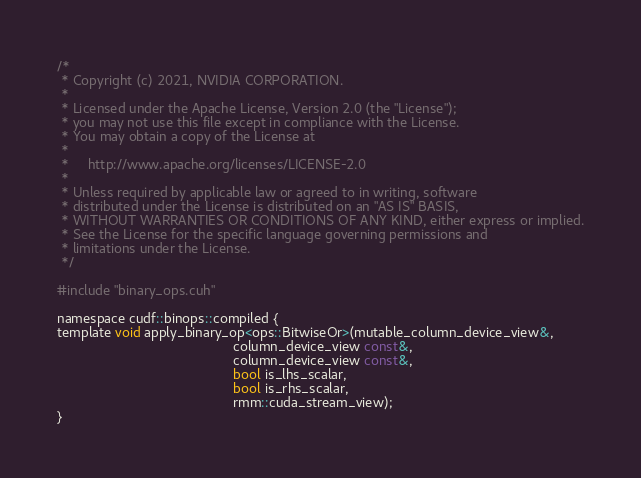<code> <loc_0><loc_0><loc_500><loc_500><_Cuda_>/*
 * Copyright (c) 2021, NVIDIA CORPORATION.
 *
 * Licensed under the Apache License, Version 2.0 (the "License");
 * you may not use this file except in compliance with the License.
 * You may obtain a copy of the License at
 *
 *     http://www.apache.org/licenses/LICENSE-2.0
 *
 * Unless required by applicable law or agreed to in writing, software
 * distributed under the License is distributed on an "AS IS" BASIS,
 * WITHOUT WARRANTIES OR CONDITIONS OF ANY KIND, either express or implied.
 * See the License for the specific language governing permissions and
 * limitations under the License.
 */

#include "binary_ops.cuh"

namespace cudf::binops::compiled {
template void apply_binary_op<ops::BitwiseOr>(mutable_column_device_view&,
                                              column_device_view const&,
                                              column_device_view const&,
                                              bool is_lhs_scalar,
                                              bool is_rhs_scalar,
                                              rmm::cuda_stream_view);
}
</code> 